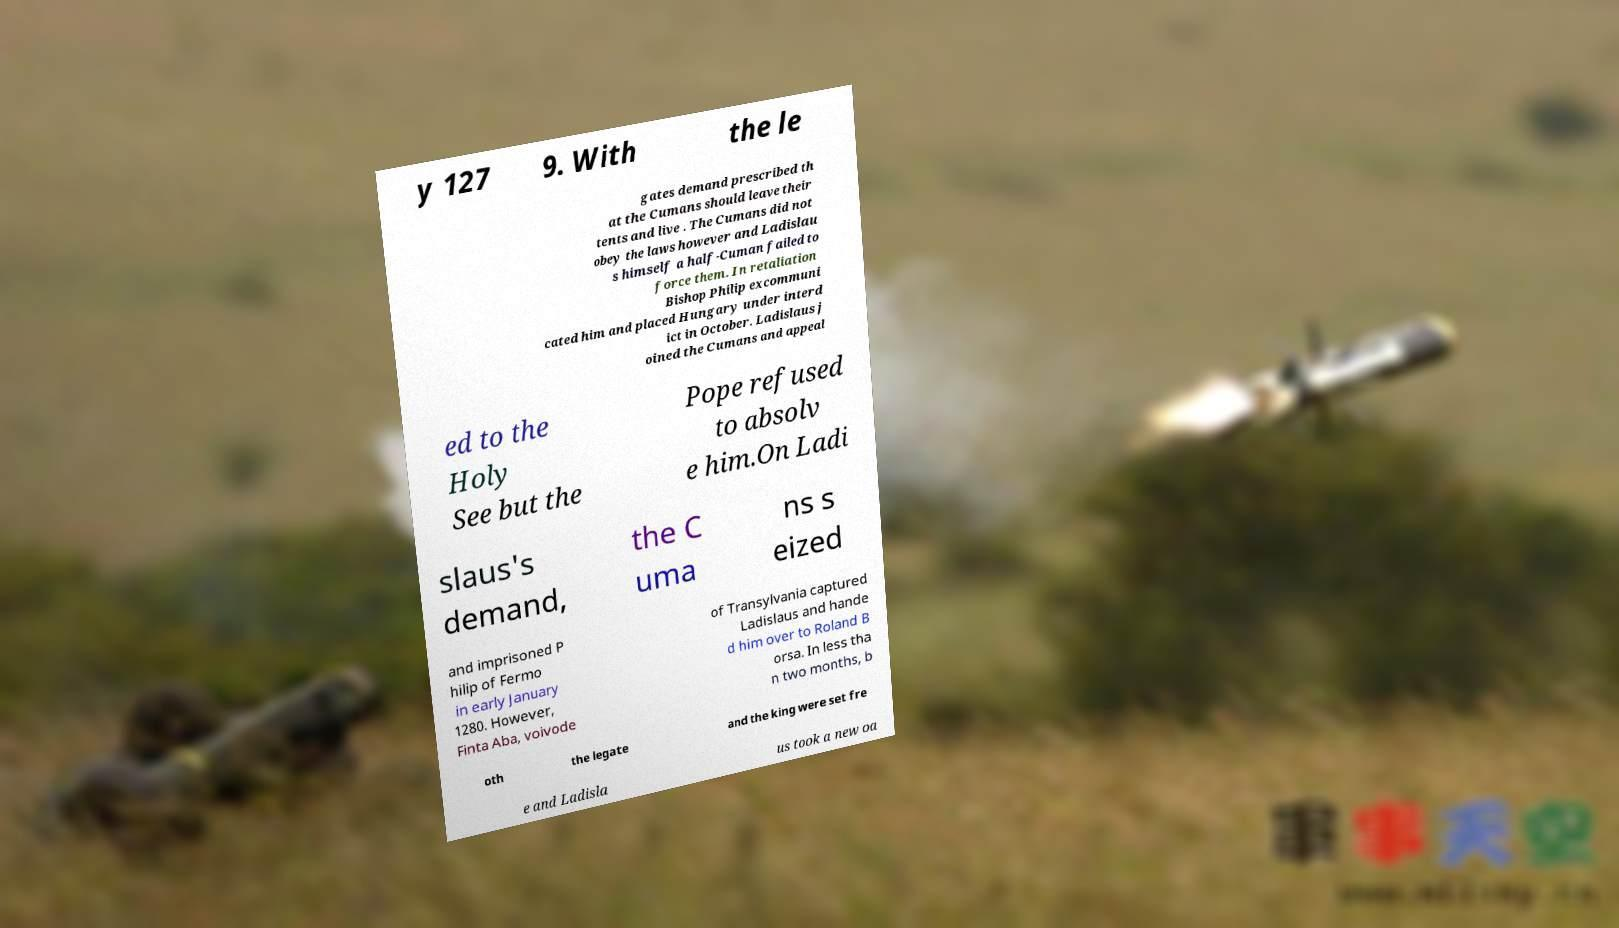Can you accurately transcribe the text from the provided image for me? y 127 9. With the le gates demand prescribed th at the Cumans should leave their tents and live . The Cumans did not obey the laws however and Ladislau s himself a half-Cuman failed to force them. In retaliation Bishop Philip excommuni cated him and placed Hungary under interd ict in October. Ladislaus j oined the Cumans and appeal ed to the Holy See but the Pope refused to absolv e him.On Ladi slaus's demand, the C uma ns s eized and imprisoned P hilip of Fermo in early January 1280. However, Finta Aba, voivode of Transylvania captured Ladislaus and hande d him over to Roland B orsa. In less tha n two months, b oth the legate and the king were set fre e and Ladisla us took a new oa 